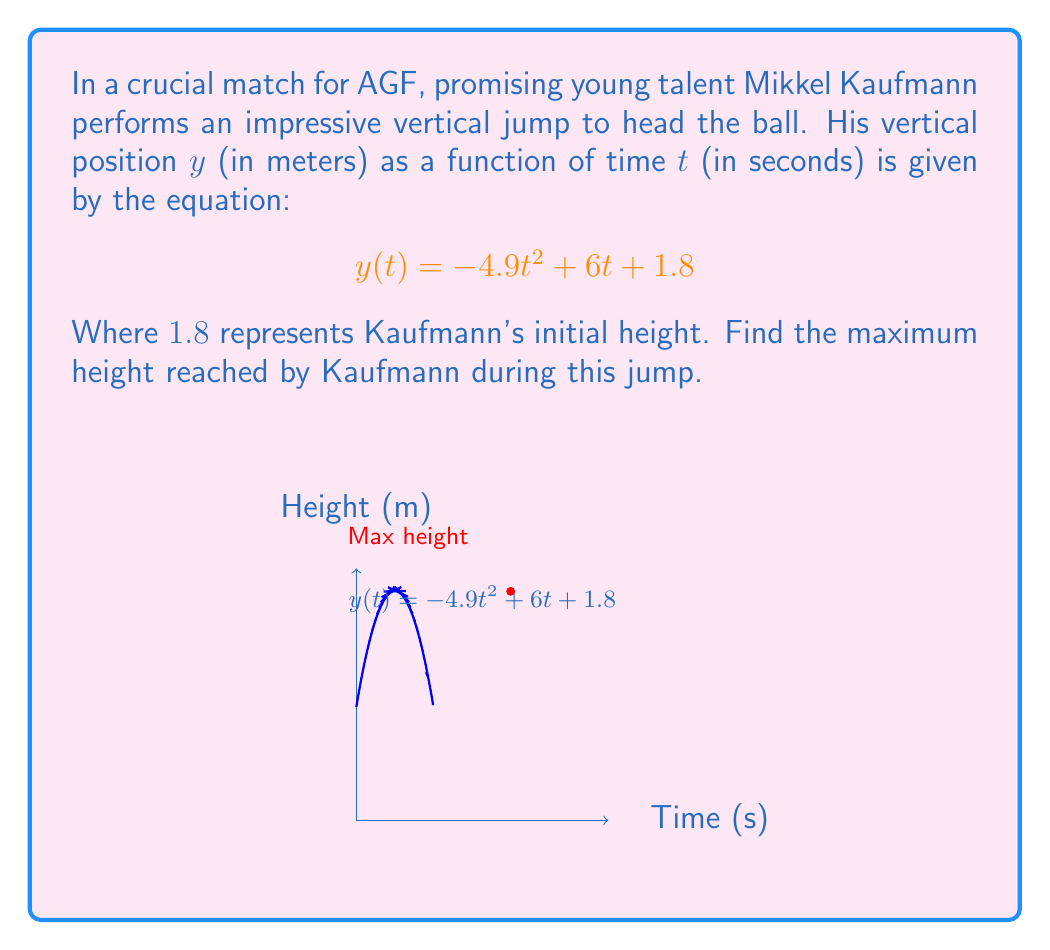Provide a solution to this math problem. To find the maximum height, we need to follow these steps:

1) The maximum height occurs when the vertical velocity is zero. The vertical velocity is given by the derivative of the position function:

   $$y'(t) = \frac{dy}{dt} = -9.8t + 6$$

2) Set the velocity to zero and solve for $t$:

   $$-9.8t + 6 = 0$$
   $$9.8t = 6$$
   $$t = \frac{6}{9.8} = 0.612 \text{ seconds}$$

3) Now that we know the time at which the maximum height occurs, we can substitute this value back into the original function to find the maximum height:

   $$y(0.612) = -4.9(0.612)^2 + 6(0.612) + 1.8$$
   $$= -4.9(0.374544) + 3.672 + 1.8$$
   $$= -1.835 + 3.672 + 1.8$$
   $$= 3.637 \text{ meters}$$

Therefore, Mikkel Kaufmann reaches a maximum height of approximately 3.637 meters during his jump.
Answer: $3.637$ meters 